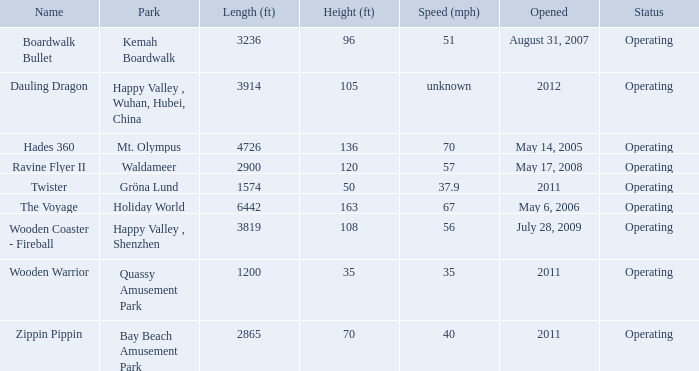What is the distance covered by the roller coaster on kemah boardwalk? 3236.0. 